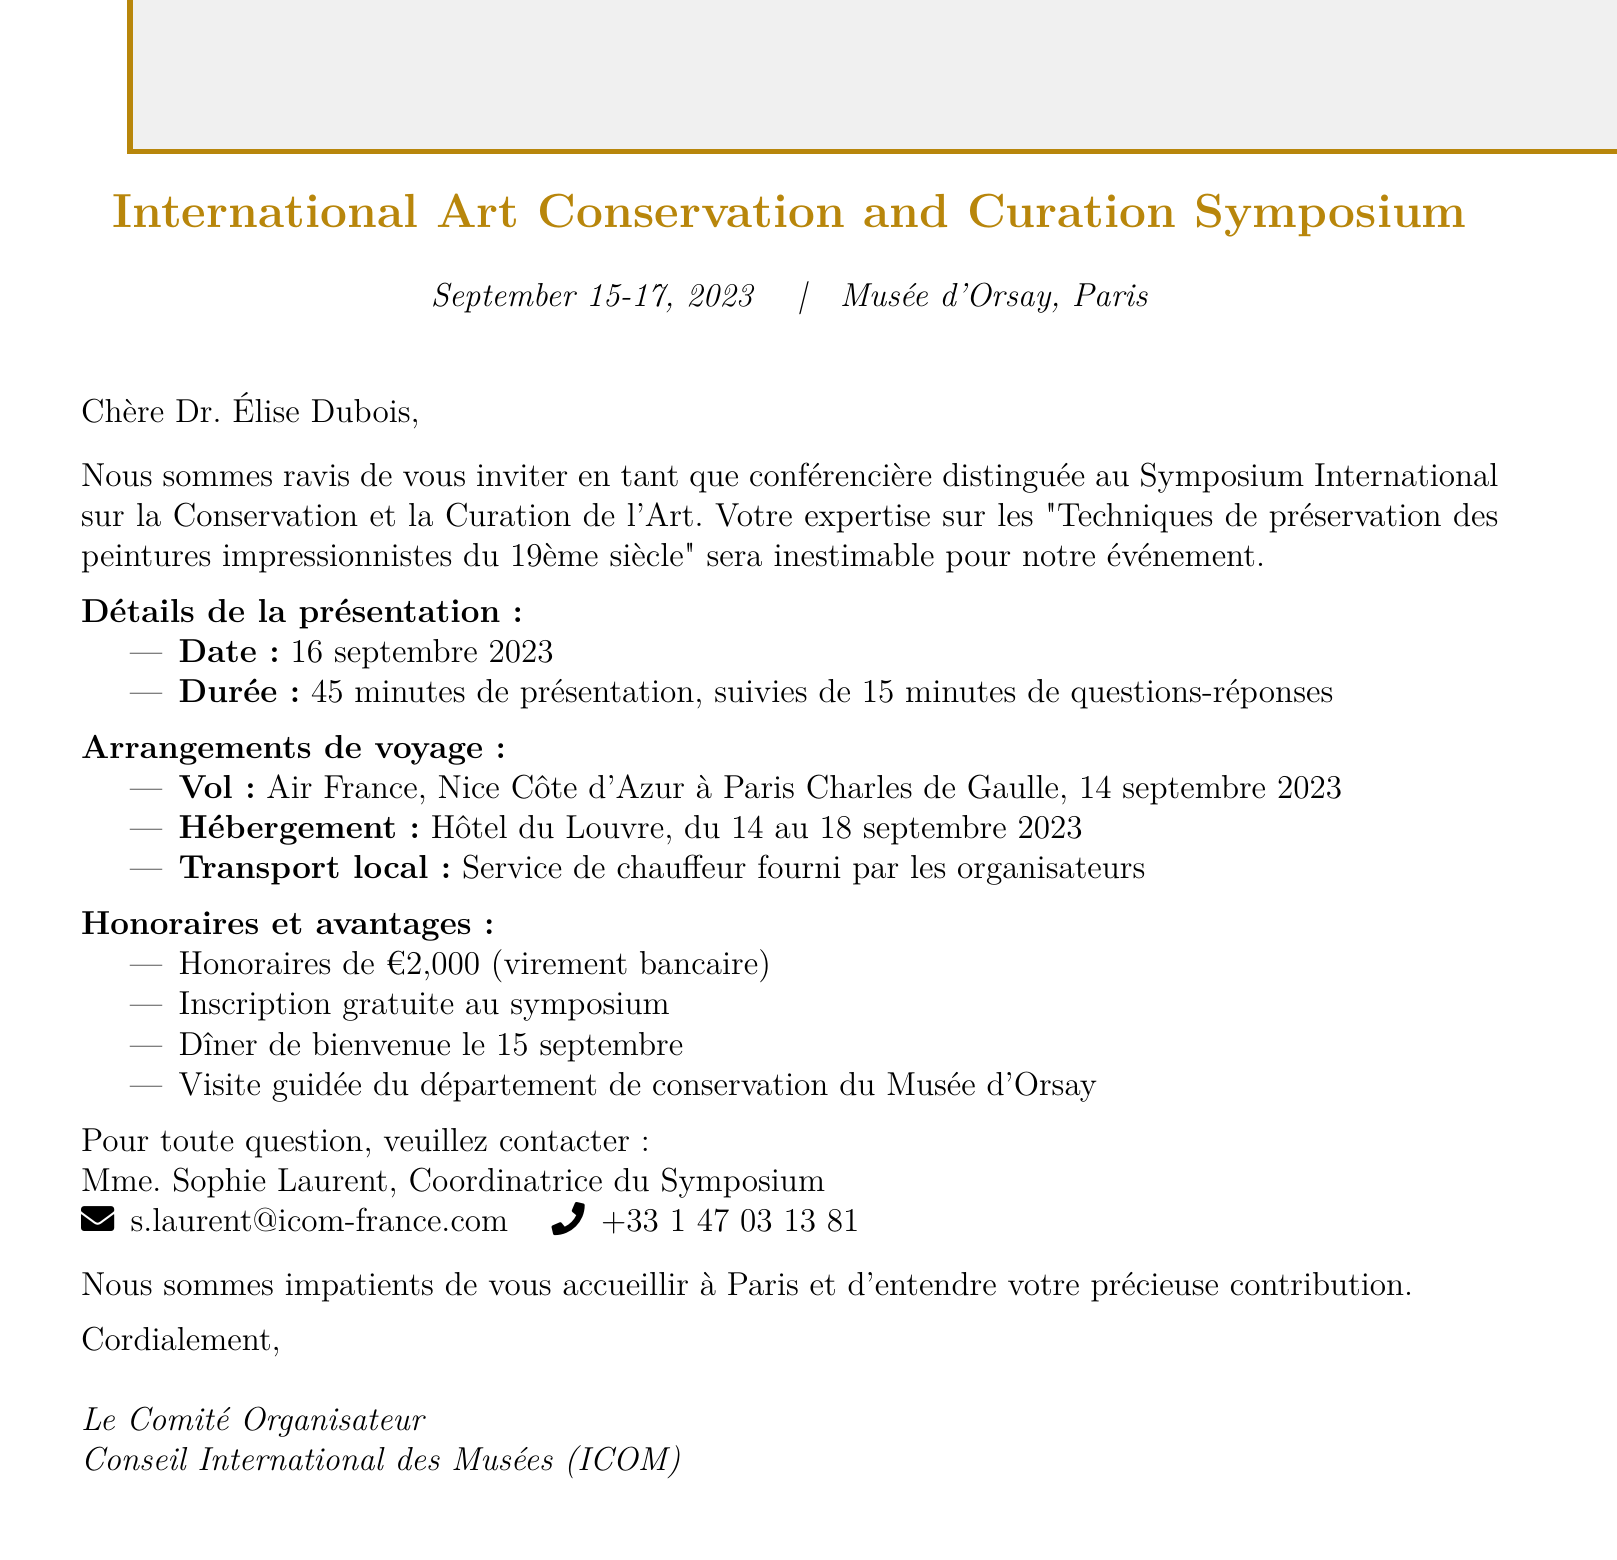What is the name of the symposium? The name of the symposium is stated in the document as "International Art Conservation and Curation Symposium."
Answer: International Art Conservation and Curation Symposium What are the dates of the symposium? The dates of the symposium are included in the introduction of the document.
Answer: September 15-17, 2023 Who is the invited speaker? The document specifies Dr. Élise Dubois as the invited speaker.
Answer: Dr. Élise Dubois What is the topic of the presentation? The topic for the speaker's presentation is explicitly mentioned in the document.
Answer: Preservation Techniques for 19th Century Impressionist Paintings What is the honorarium amount? The document mentions the honorarium amount clearly.
Answer: €2,000 What airline is used for the flight? The document specifies the airline for the travel arrangements.
Answer: Air France What is the hotel name for accommodation? The hotel for accommodation is stated in the travel arrangements section of the document.
Answer: Hôtel du Louvre On which date is the welcome dinner? The date of the welcome dinner is provided as part of the additional benefits.
Answer: September 15 How long is the presentation duration? The duration of the presentation is stated clearly in the document.
Answer: 45 minutes followed by 15 minutes of Q&A Who is the contact person for the symposium? The contact person is introduced at the end of the document.
Answer: Mme. Sophie Laurent 